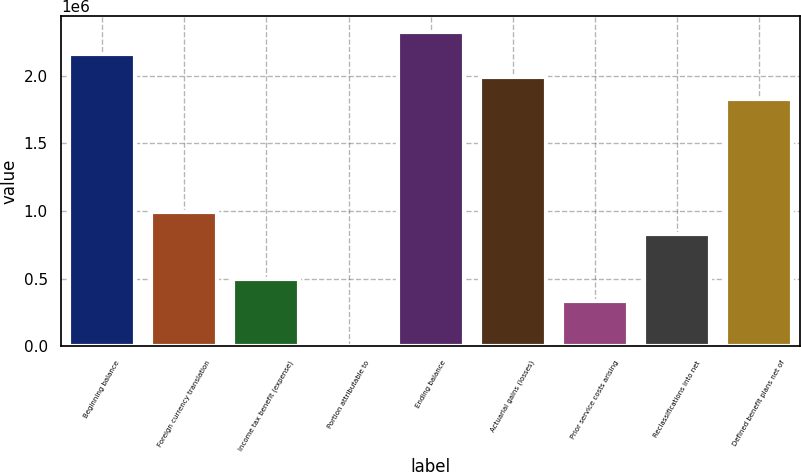Convert chart to OTSL. <chart><loc_0><loc_0><loc_500><loc_500><bar_chart><fcel>Beginning balance<fcel>Foreign currency translation<fcel>Income tax benefit (expense)<fcel>Portion attributable to<fcel>Ending balance<fcel>Actuarial gains (losses)<fcel>Prior service costs arising<fcel>Reclassifications into net<fcel>Defined benefit plans net of<nl><fcel>2.16003e+06<fcel>997310<fcel>499002<fcel>695<fcel>2.32613e+06<fcel>1.99392e+06<fcel>332900<fcel>831208<fcel>1.82782e+06<nl></chart> 